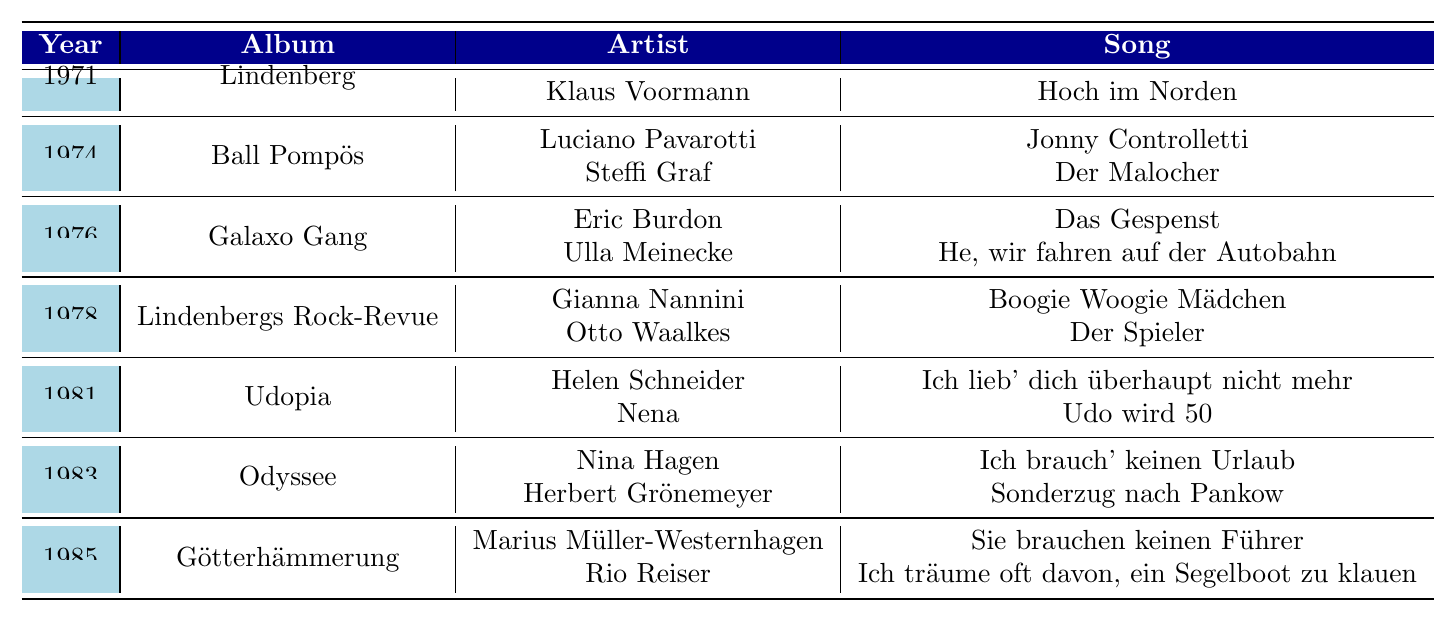What year did Udo Lindenberg collaborate with Klaus Voormann? The table shows that Klaus Voormann collaborated with Udo Lindenberg on the song "Hoch im Norden," which is listed under the year 1971.
Answer: 1971 How many collaborations are listed for the album "Odyssee"? Under the album "Odyssee," there are two collaborations: one with Nina Hagen and another with Herbert Grönemeyer.
Answer: 2 Which artist collaborated with Udo Lindenberg in 1974? Looking at the year 1974, the table shows two artists: Luciano Pavarotti and Steffi Graf collaborated with Udo Lindenberg on the album "Ball Pompös."
Answer: Luciano Pavarotti and Steffi Graf What is the sum of all the collaborations listed across the years? The total number of collaborations is calculated by counting each entry. There are 10 collaborations across the albums: 1 (1971) + 2 (1974) + 2 (1976) + 2 (1978) + 2 (1981) + 2 (1983) + 2 (1985) = 10.
Answer: 10 Which album features a collaboration between Udo Lindenberg and Eric Burdon? Eric Burdon collaborated on the album "Galaxo Gang," which is listed in the year 1976.
Answer: Galaxo Gang Did Udo Lindenberg collaborate with any female artists on the album "Udopia"? The album "Udopia," listed under 1981, includes a collaboration with Helen Schneider, a female artist, indicating that there was indeed a collaboration with a female artist on this album.
Answer: Yes What is the difference in the number of collaborations between the years 1981 and 1985? In 1981, there were 2 collaborations listed under the album "Udopia," and in 1985, there were also 2 listed under "Götterhämmerung." The difference between these two numbers is 2 - 2 = 0.
Answer: 0 Which collaboration involved the artist Nena, and what year was it? The table indicates that the artist Nena collaborated on the song "Udo wird 50" in the year 1981 on the album "Udopia."
Answer: 1981, Udo wird 50 Who were the two artists that collaborated with Udo Lindenberg on the album "Götterhämmerung"? The table shows that Marius Müller-Westernhagen and Rio Reiser collaborated with Udo Lindenberg on the album "Götterhämmerung" in 1985.
Answer: Marius Müller-Westernhagen and Rio Reiser Which artist collaborated the most with Udo Lindenberg based on the data from 1971 to 1985? Analyzing the data, each artist appears only once; however, if considering the data in total, no single artist appears more than once, so the answer is that no artist collaborated more than others.
Answer: None 